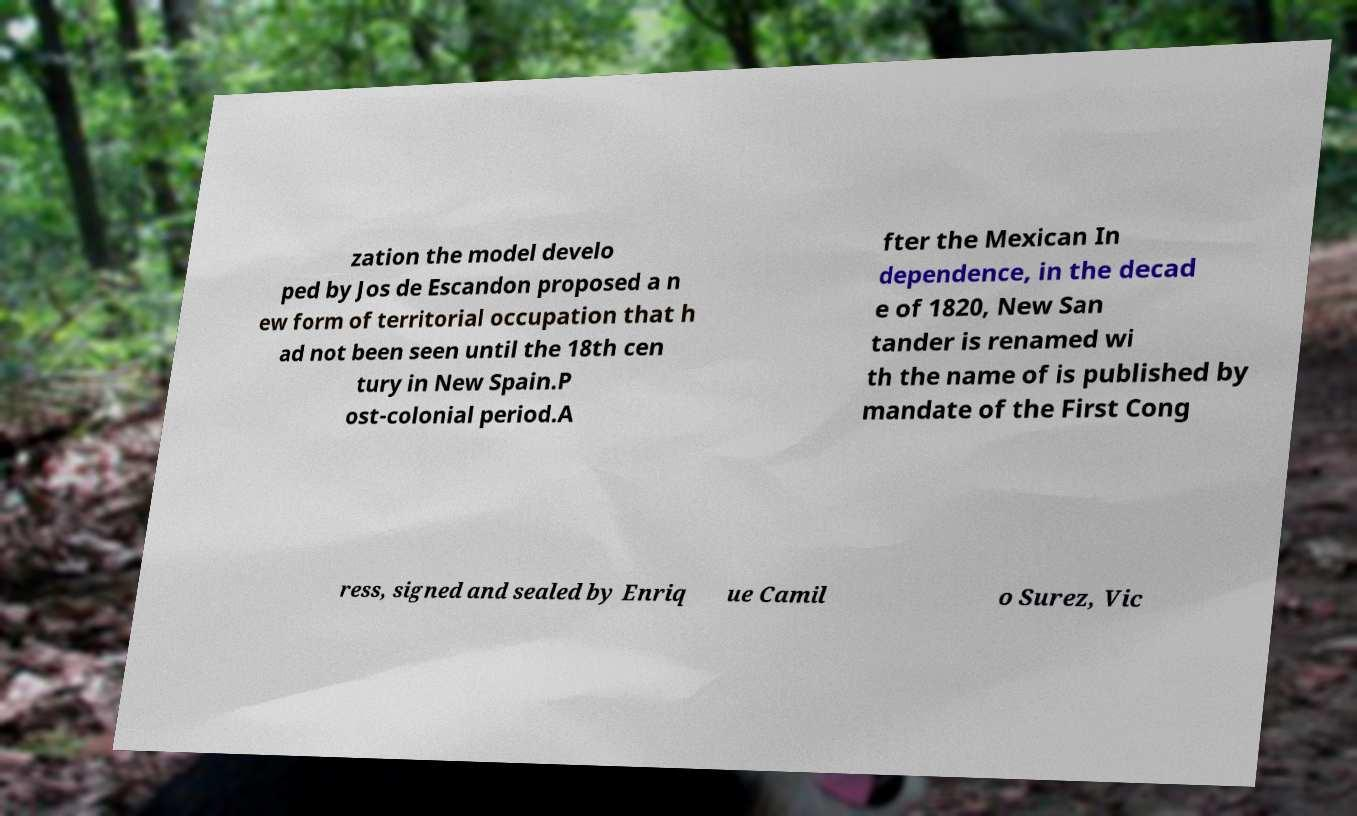Can you read and provide the text displayed in the image?This photo seems to have some interesting text. Can you extract and type it out for me? zation the model develo ped by Jos de Escandon proposed a n ew form of territorial occupation that h ad not been seen until the 18th cen tury in New Spain.P ost-colonial period.A fter the Mexican In dependence, in the decad e of 1820, New San tander is renamed wi th the name of is published by mandate of the First Cong ress, signed and sealed by Enriq ue Camil o Surez, Vic 